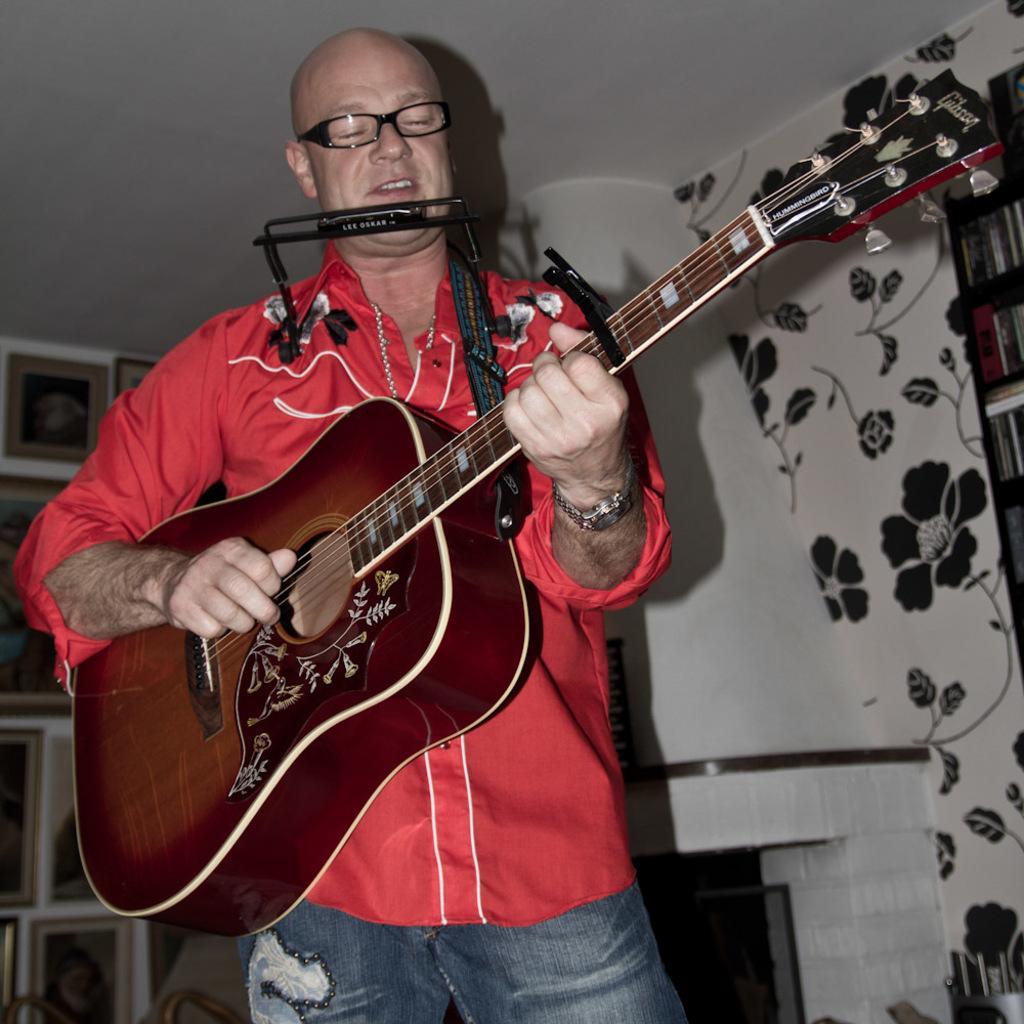Please provide a concise description of this image. In the image we can see a man who is wearing a red shirt and spectacles is playing guitar. 